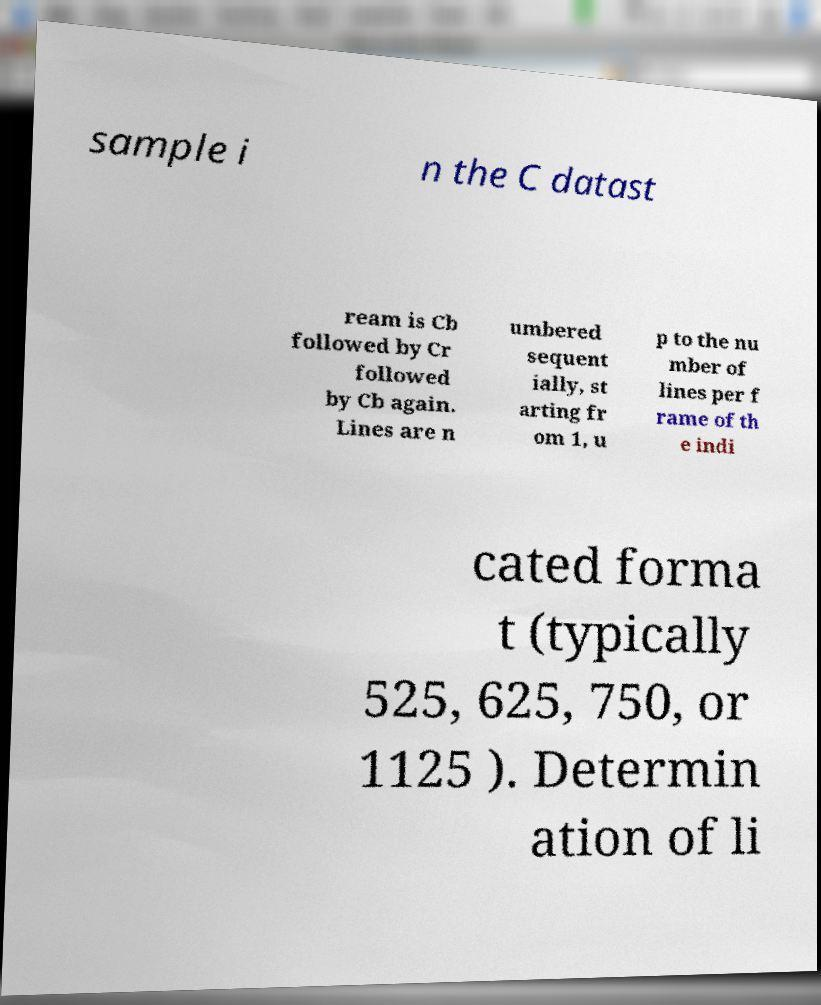Can you accurately transcribe the text from the provided image for me? sample i n the C datast ream is Cb followed by Cr followed by Cb again. Lines are n umbered sequent ially, st arting fr om 1, u p to the nu mber of lines per f rame of th e indi cated forma t (typically 525, 625, 750, or 1125 ). Determin ation of li 